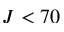<formula> <loc_0><loc_0><loc_500><loc_500>J < 7 0</formula> 